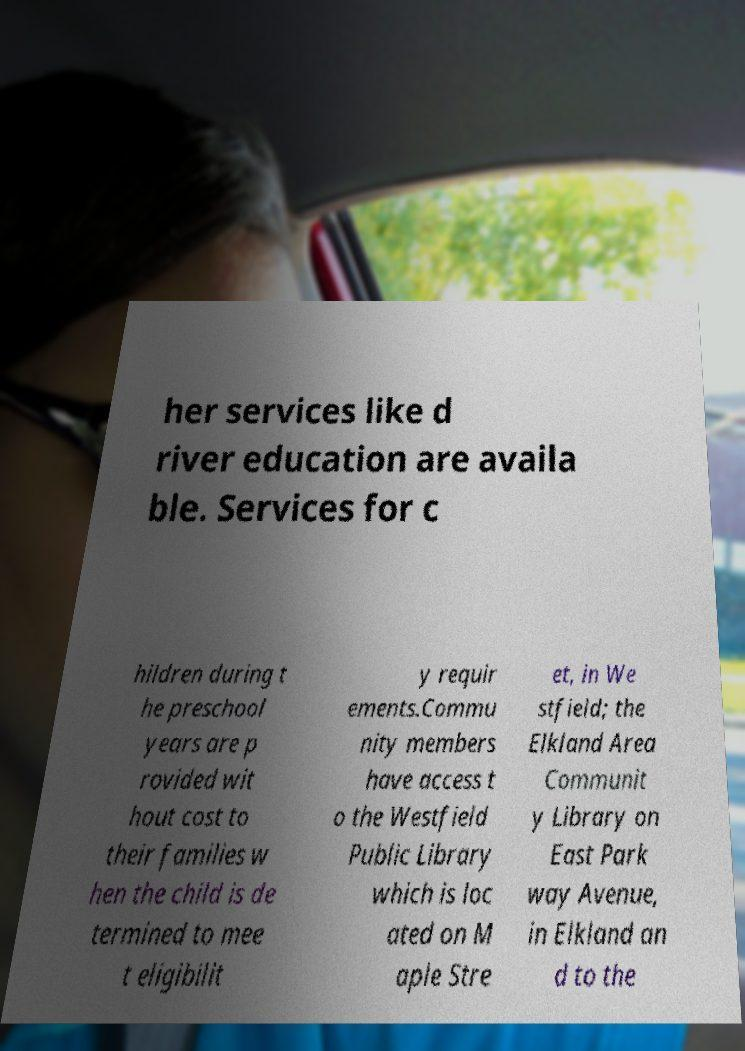What messages or text are displayed in this image? I need them in a readable, typed format. her services like d river education are availa ble. Services for c hildren during t he preschool years are p rovided wit hout cost to their families w hen the child is de termined to mee t eligibilit y requir ements.Commu nity members have access t o the Westfield Public Library which is loc ated on M aple Stre et, in We stfield; the Elkland Area Communit y Library on East Park way Avenue, in Elkland an d to the 